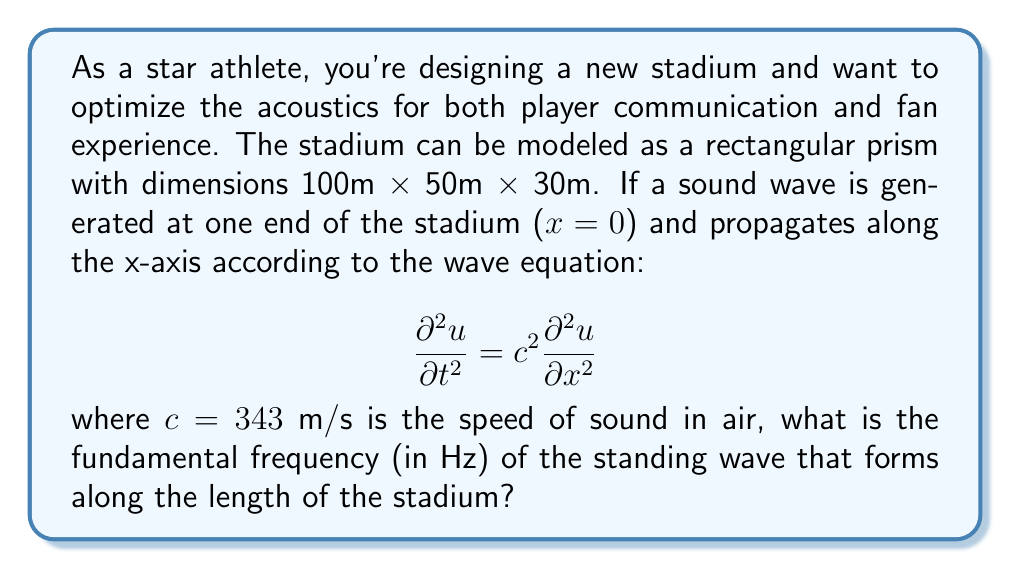What is the answer to this math problem? Let's approach this step-by-step:

1) For a standing wave in a rectangular enclosure, we need to consider the boundary conditions. At both ends of the stadium (x = 0 and x = L), the displacement of the wave should be zero (nodes).

2) The general solution for a standing wave along the x-axis is:

   $$ u(x,t) = A \sin(kx) \cos(\omega t) $$

   where k is the wave number and ω is the angular frequency.

3) To satisfy the boundary conditions:
   At x = 0: $u(0,t) = 0$ (always true)
   At x = L: $u(L,t) = A \sin(kL) \cos(\omega t) = 0$

4) For the second condition to be true for all t, we must have:

   $$ kL = n\pi $$

   where n is a positive integer.

5) The fundamental frequency corresponds to n = 1, so:

   $$ k = \frac{\pi}{L} $$

6) We know that $\omega = ck$ for a wave, where c is the wave speed. So:

   $$ \omega = c\frac{\pi}{L} $$

7) The frequency f is related to ω by $\omega = 2\pi f$, so:

   $$ f = \frac{c}{2L} $$

8) Plugging in the values (c = 343 m/s, L = 100 m):

   $$ f = \frac{343}{2(100)} = 1.715 \text{ Hz} $$
Answer: 1.715 Hz 